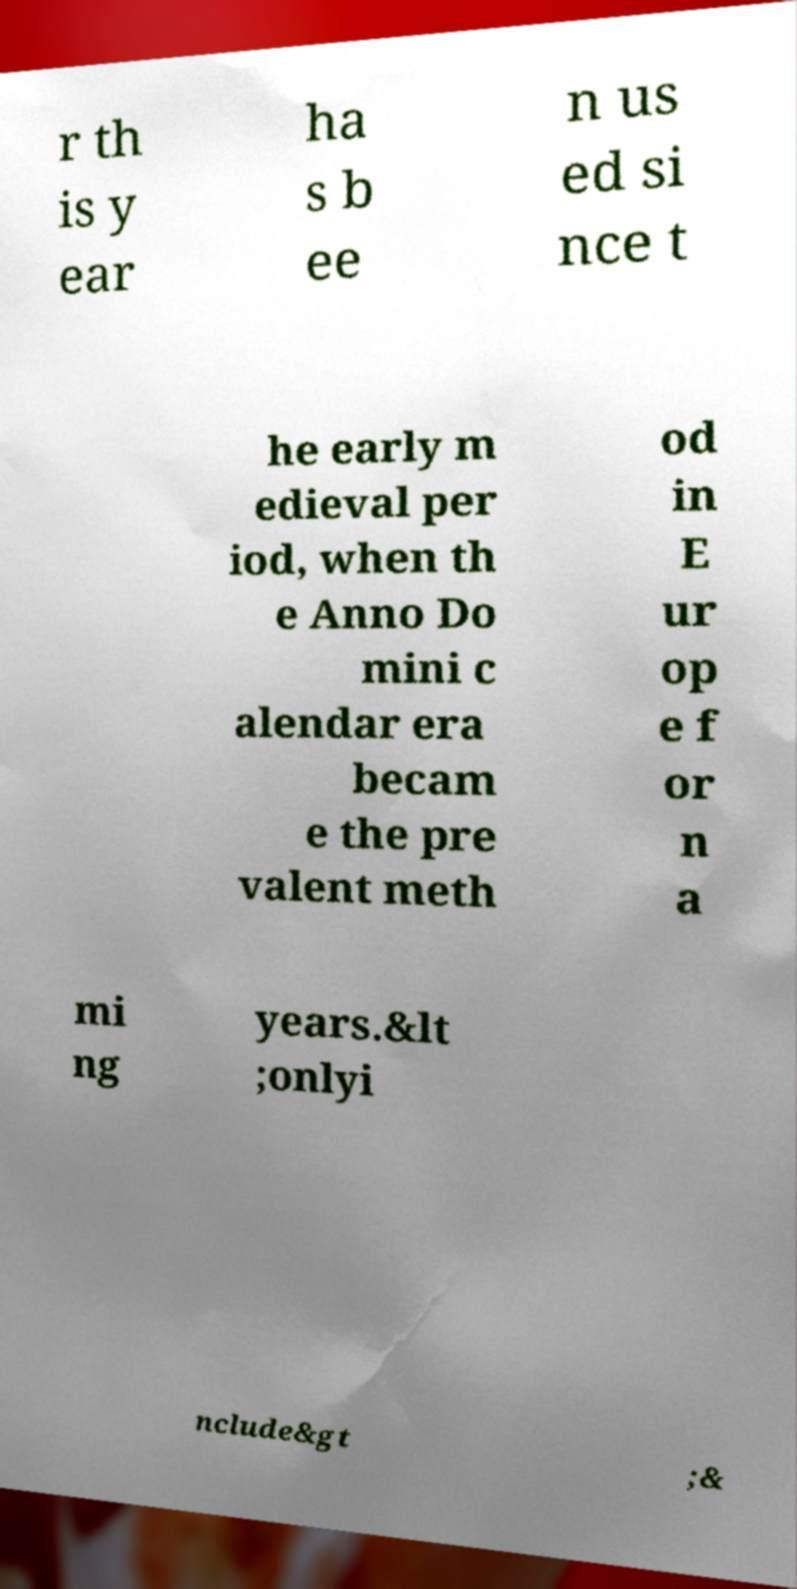Please read and relay the text visible in this image. What does it say? r th is y ear ha s b ee n us ed si nce t he early m edieval per iod, when th e Anno Do mini c alendar era becam e the pre valent meth od in E ur op e f or n a mi ng years.&lt ;onlyi nclude&gt ;& 